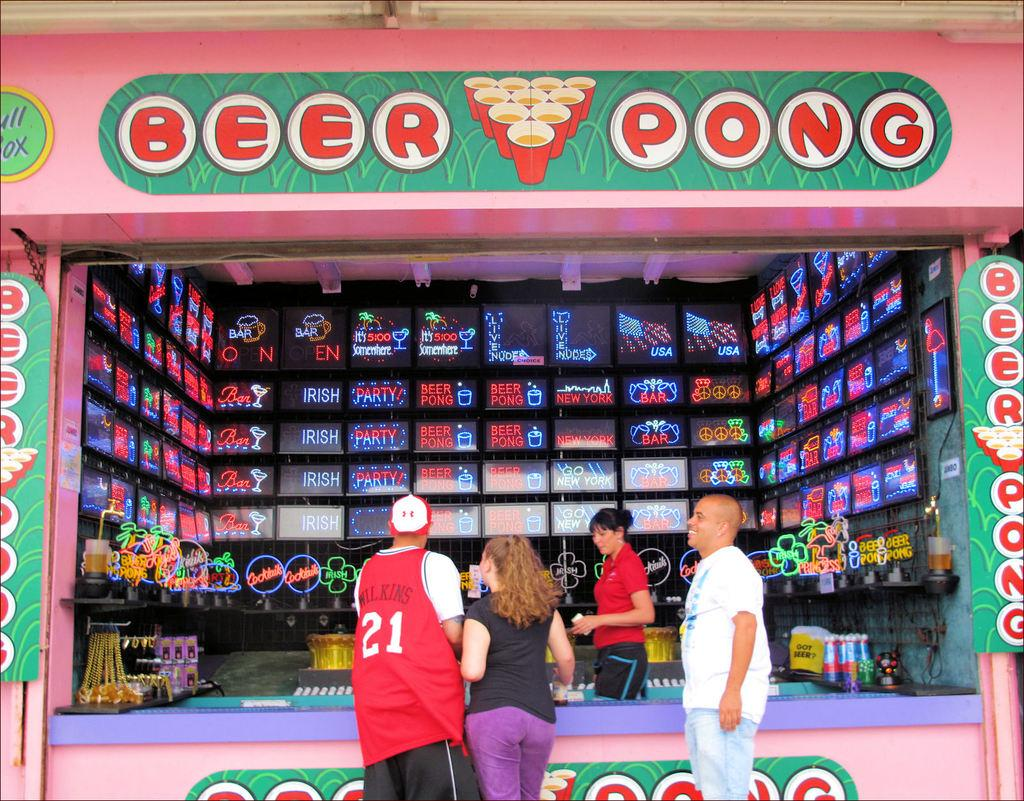<image>
Describe the image concisely. A Beer pong booth at a carnival has people standing in front of it. 